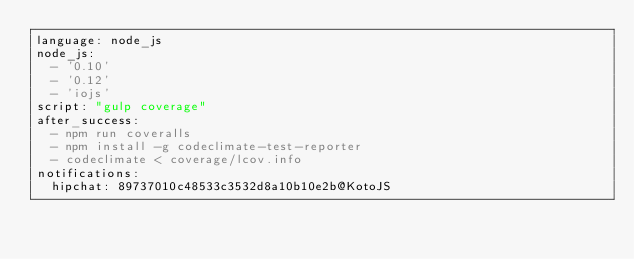<code> <loc_0><loc_0><loc_500><loc_500><_YAML_>language: node_js
node_js:
  - '0.10'
  - '0.12'
  - 'iojs'
script: "gulp coverage"
after_success:
  - npm run coveralls
  - npm install -g codeclimate-test-reporter
  - codeclimate < coverage/lcov.info
notifications:
  hipchat: 89737010c48533c3532d8a10b10e2b@KotoJS
</code> 